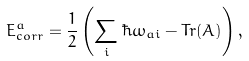<formula> <loc_0><loc_0><loc_500><loc_500>E ^ { a } _ { c o r r } = \frac { 1 } { 2 } \left ( \sum _ { i } \hbar { \omega } _ { a i } - T r ( A ) \right ) ,</formula> 